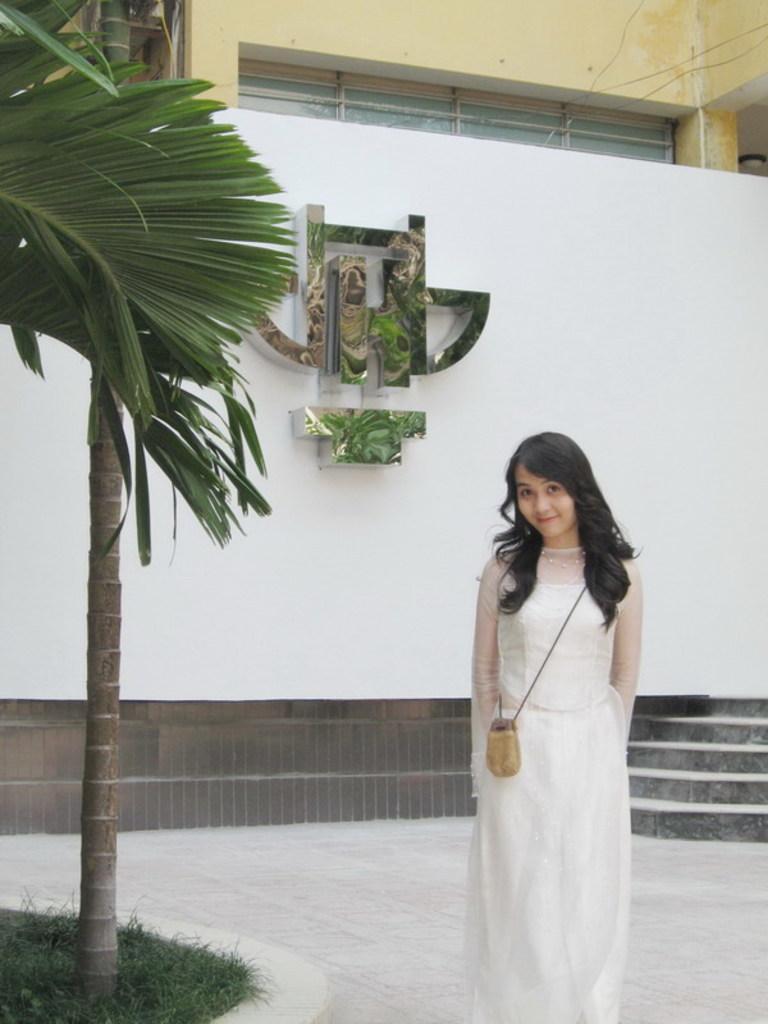Can you describe this image briefly? In this picture I can see a woman is standing on the ground. The woman is wearing white color dress and smiling. In the background I can see steps and white color wall on which I can see an object attached to it. On the left side I can see trees and grass. 